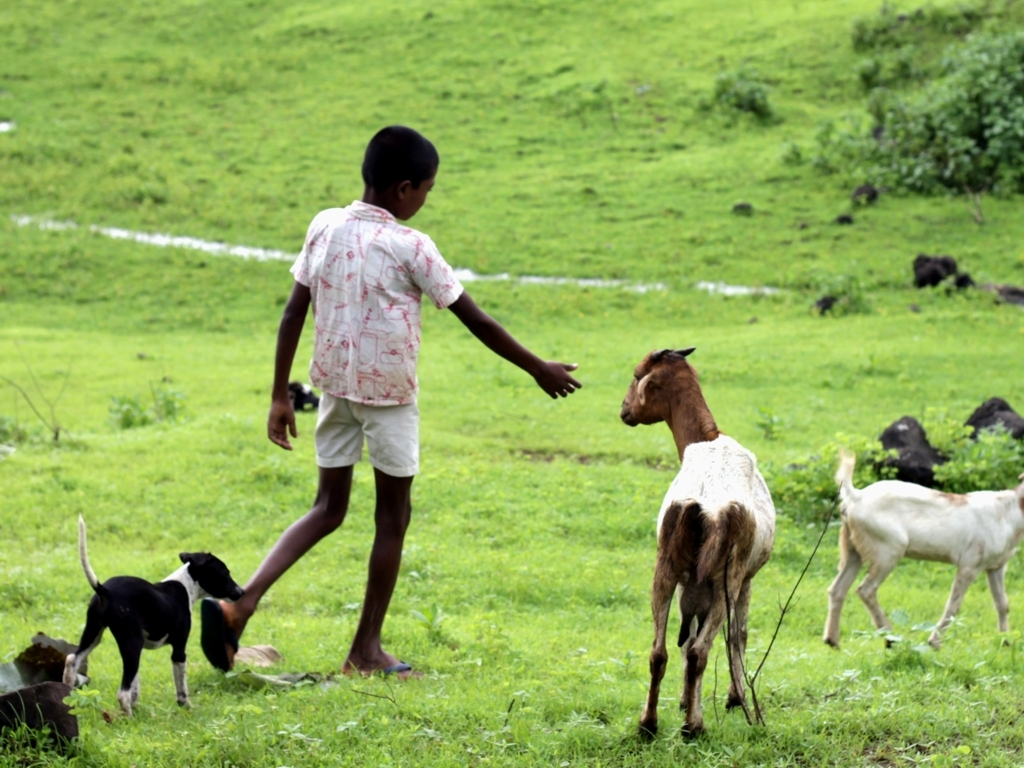Can you describe the setting and mood of this photograph? This photograph captures a pastoral scene brimming with tranquility. A child stands in an open, grassy field surrounded by goats and a couple of dogs. The overcast sky softens the light, contributing to the serene atmosphere. The expanse of green implies that this location is likely rural, where nature and agriculture play significant roles in daily life. What can be inferred about the child's relationship with the animals? The body language and proximity of the child to the animals suggest a sense of familiarity and comfort with each other. It's reasonable to infer that the child may have responsibilities in caring for the goats, such as herding or feeding, which often fosters a close bond. 